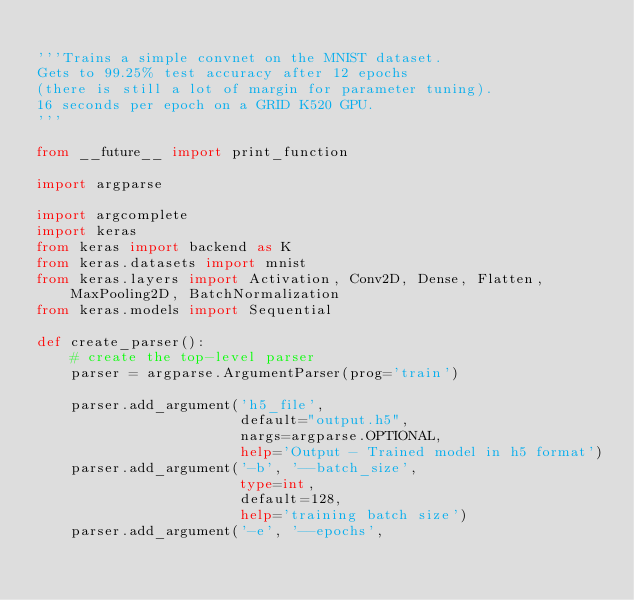Convert code to text. <code><loc_0><loc_0><loc_500><loc_500><_Python_>
'''Trains a simple convnet on the MNIST dataset.
Gets to 99.25% test accuracy after 12 epochs
(there is still a lot of margin for parameter tuning).
16 seconds per epoch on a GRID K520 GPU.
'''

from __future__ import print_function

import argparse

import argcomplete
import keras
from keras import backend as K
from keras.datasets import mnist
from keras.layers import Activation, Conv2D, Dense, Flatten, MaxPooling2D, BatchNormalization
from keras.models import Sequential

def create_parser():
    # create the top-level parser
    parser = argparse.ArgumentParser(prog='train')

    parser.add_argument('h5_file',
                        default="output.h5",
                        nargs=argparse.OPTIONAL,
                        help='Output - Trained model in h5 format')
    parser.add_argument('-b', '--batch_size',
                        type=int,
                        default=128,
                        help='training batch size')
    parser.add_argument('-e', '--epochs',</code> 